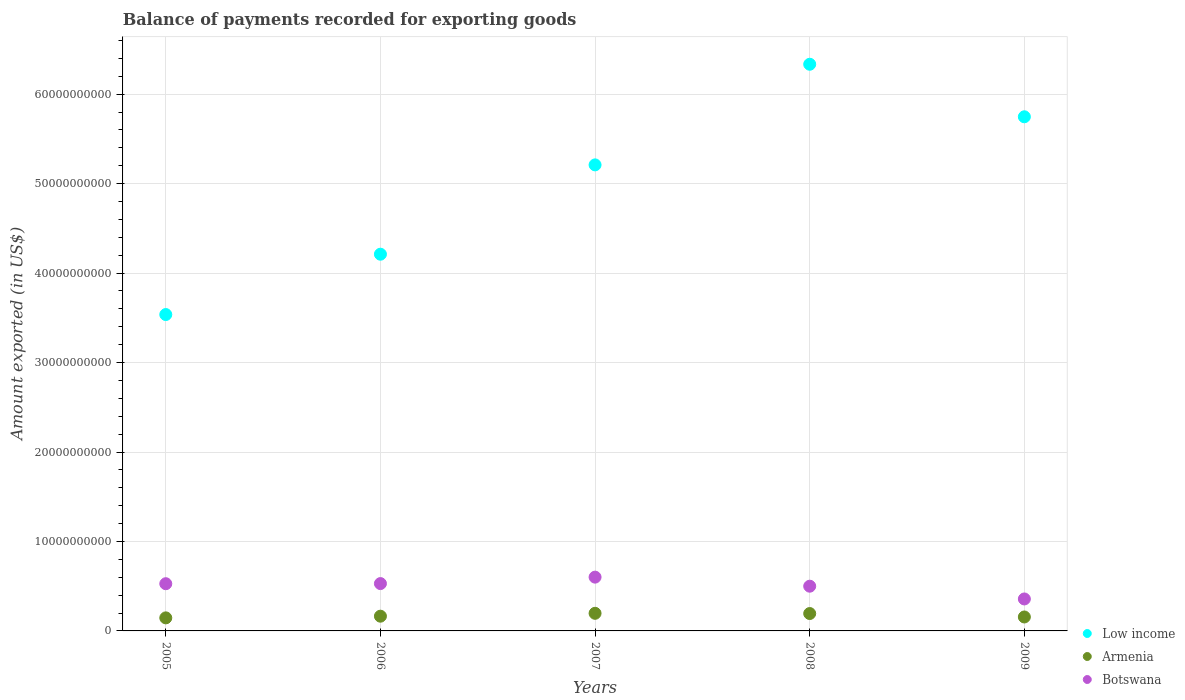How many different coloured dotlines are there?
Provide a succinct answer. 3. What is the amount exported in Low income in 2008?
Offer a very short reply. 6.33e+1. Across all years, what is the maximum amount exported in Low income?
Keep it short and to the point. 6.33e+1. Across all years, what is the minimum amount exported in Armenia?
Keep it short and to the point. 1.46e+09. In which year was the amount exported in Low income maximum?
Make the answer very short. 2008. In which year was the amount exported in Low income minimum?
Keep it short and to the point. 2005. What is the total amount exported in Armenia in the graph?
Ensure brevity in your answer.  8.58e+09. What is the difference between the amount exported in Botswana in 2007 and that in 2009?
Provide a short and direct response. 2.44e+09. What is the difference between the amount exported in Low income in 2005 and the amount exported in Armenia in 2007?
Make the answer very short. 3.34e+1. What is the average amount exported in Low income per year?
Offer a very short reply. 5.01e+1. In the year 2005, what is the difference between the amount exported in Botswana and amount exported in Armenia?
Provide a short and direct response. 3.82e+09. In how many years, is the amount exported in Low income greater than 26000000000 US$?
Give a very brief answer. 5. What is the ratio of the amount exported in Armenia in 2008 to that in 2009?
Your answer should be compact. 1.25. What is the difference between the highest and the second highest amount exported in Armenia?
Provide a succinct answer. 2.48e+07. What is the difference between the highest and the lowest amount exported in Armenia?
Give a very brief answer. 5.10e+08. In how many years, is the amount exported in Armenia greater than the average amount exported in Armenia taken over all years?
Give a very brief answer. 2. Does the amount exported in Armenia monotonically increase over the years?
Provide a short and direct response. No. Is the amount exported in Botswana strictly greater than the amount exported in Low income over the years?
Provide a short and direct response. No. Are the values on the major ticks of Y-axis written in scientific E-notation?
Provide a short and direct response. No. Does the graph contain grids?
Give a very brief answer. Yes. How many legend labels are there?
Your answer should be compact. 3. What is the title of the graph?
Your response must be concise. Balance of payments recorded for exporting goods. What is the label or title of the Y-axis?
Make the answer very short. Amount exported (in US$). What is the Amount exported (in US$) in Low income in 2005?
Your response must be concise. 3.54e+1. What is the Amount exported (in US$) in Armenia in 2005?
Keep it short and to the point. 1.46e+09. What is the Amount exported (in US$) in Botswana in 2005?
Your response must be concise. 5.28e+09. What is the Amount exported (in US$) of Low income in 2006?
Ensure brevity in your answer.  4.21e+1. What is the Amount exported (in US$) of Armenia in 2006?
Give a very brief answer. 1.65e+09. What is the Amount exported (in US$) in Botswana in 2006?
Your answer should be compact. 5.29e+09. What is the Amount exported (in US$) of Low income in 2007?
Offer a terse response. 5.21e+1. What is the Amount exported (in US$) in Armenia in 2007?
Keep it short and to the point. 1.97e+09. What is the Amount exported (in US$) in Botswana in 2007?
Offer a very short reply. 6.01e+09. What is the Amount exported (in US$) in Low income in 2008?
Offer a very short reply. 6.33e+1. What is the Amount exported (in US$) in Armenia in 2008?
Provide a short and direct response. 1.94e+09. What is the Amount exported (in US$) of Botswana in 2008?
Give a very brief answer. 5.00e+09. What is the Amount exported (in US$) in Low income in 2009?
Keep it short and to the point. 5.75e+1. What is the Amount exported (in US$) of Armenia in 2009?
Provide a succinct answer. 1.56e+09. What is the Amount exported (in US$) in Botswana in 2009?
Provide a succinct answer. 3.57e+09. Across all years, what is the maximum Amount exported (in US$) in Low income?
Your answer should be very brief. 6.33e+1. Across all years, what is the maximum Amount exported (in US$) of Armenia?
Provide a succinct answer. 1.97e+09. Across all years, what is the maximum Amount exported (in US$) of Botswana?
Provide a short and direct response. 6.01e+09. Across all years, what is the minimum Amount exported (in US$) of Low income?
Offer a terse response. 3.54e+1. Across all years, what is the minimum Amount exported (in US$) of Armenia?
Offer a very short reply. 1.46e+09. Across all years, what is the minimum Amount exported (in US$) in Botswana?
Ensure brevity in your answer.  3.57e+09. What is the total Amount exported (in US$) in Low income in the graph?
Provide a short and direct response. 2.50e+11. What is the total Amount exported (in US$) in Armenia in the graph?
Keep it short and to the point. 8.58e+09. What is the total Amount exported (in US$) in Botswana in the graph?
Keep it short and to the point. 2.52e+1. What is the difference between the Amount exported (in US$) of Low income in 2005 and that in 2006?
Make the answer very short. -6.74e+09. What is the difference between the Amount exported (in US$) in Armenia in 2005 and that in 2006?
Offer a terse response. -1.88e+08. What is the difference between the Amount exported (in US$) in Botswana in 2005 and that in 2006?
Provide a succinct answer. -1.42e+07. What is the difference between the Amount exported (in US$) in Low income in 2005 and that in 2007?
Provide a succinct answer. -1.67e+1. What is the difference between the Amount exported (in US$) in Armenia in 2005 and that in 2007?
Keep it short and to the point. -5.10e+08. What is the difference between the Amount exported (in US$) in Botswana in 2005 and that in 2007?
Your answer should be very brief. -7.35e+08. What is the difference between the Amount exported (in US$) of Low income in 2005 and that in 2008?
Provide a short and direct response. -2.80e+1. What is the difference between the Amount exported (in US$) of Armenia in 2005 and that in 2008?
Provide a short and direct response. -4.85e+08. What is the difference between the Amount exported (in US$) of Botswana in 2005 and that in 2008?
Your answer should be very brief. 2.78e+08. What is the difference between the Amount exported (in US$) of Low income in 2005 and that in 2009?
Make the answer very short. -2.21e+1. What is the difference between the Amount exported (in US$) of Armenia in 2005 and that in 2009?
Keep it short and to the point. -1.00e+08. What is the difference between the Amount exported (in US$) in Botswana in 2005 and that in 2009?
Provide a succinct answer. 1.70e+09. What is the difference between the Amount exported (in US$) in Low income in 2006 and that in 2007?
Ensure brevity in your answer.  -9.99e+09. What is the difference between the Amount exported (in US$) in Armenia in 2006 and that in 2007?
Your answer should be very brief. -3.22e+08. What is the difference between the Amount exported (in US$) in Botswana in 2006 and that in 2007?
Keep it short and to the point. -7.20e+08. What is the difference between the Amount exported (in US$) in Low income in 2006 and that in 2008?
Keep it short and to the point. -2.12e+1. What is the difference between the Amount exported (in US$) in Armenia in 2006 and that in 2008?
Offer a terse response. -2.97e+08. What is the difference between the Amount exported (in US$) of Botswana in 2006 and that in 2008?
Offer a very short reply. 2.92e+08. What is the difference between the Amount exported (in US$) in Low income in 2006 and that in 2009?
Give a very brief answer. -1.54e+1. What is the difference between the Amount exported (in US$) of Armenia in 2006 and that in 2009?
Offer a very short reply. 8.74e+07. What is the difference between the Amount exported (in US$) of Botswana in 2006 and that in 2009?
Give a very brief answer. 1.72e+09. What is the difference between the Amount exported (in US$) of Low income in 2007 and that in 2008?
Your response must be concise. -1.12e+1. What is the difference between the Amount exported (in US$) of Armenia in 2007 and that in 2008?
Give a very brief answer. 2.48e+07. What is the difference between the Amount exported (in US$) in Botswana in 2007 and that in 2008?
Your answer should be very brief. 1.01e+09. What is the difference between the Amount exported (in US$) in Low income in 2007 and that in 2009?
Keep it short and to the point. -5.38e+09. What is the difference between the Amount exported (in US$) in Armenia in 2007 and that in 2009?
Make the answer very short. 4.09e+08. What is the difference between the Amount exported (in US$) of Botswana in 2007 and that in 2009?
Offer a terse response. 2.44e+09. What is the difference between the Amount exported (in US$) in Low income in 2008 and that in 2009?
Your answer should be very brief. 5.87e+09. What is the difference between the Amount exported (in US$) in Armenia in 2008 and that in 2009?
Your response must be concise. 3.84e+08. What is the difference between the Amount exported (in US$) in Botswana in 2008 and that in 2009?
Offer a terse response. 1.43e+09. What is the difference between the Amount exported (in US$) of Low income in 2005 and the Amount exported (in US$) of Armenia in 2006?
Offer a terse response. 3.37e+1. What is the difference between the Amount exported (in US$) of Low income in 2005 and the Amount exported (in US$) of Botswana in 2006?
Make the answer very short. 3.01e+1. What is the difference between the Amount exported (in US$) in Armenia in 2005 and the Amount exported (in US$) in Botswana in 2006?
Your response must be concise. -3.83e+09. What is the difference between the Amount exported (in US$) in Low income in 2005 and the Amount exported (in US$) in Armenia in 2007?
Offer a very short reply. 3.34e+1. What is the difference between the Amount exported (in US$) of Low income in 2005 and the Amount exported (in US$) of Botswana in 2007?
Provide a short and direct response. 2.94e+1. What is the difference between the Amount exported (in US$) in Armenia in 2005 and the Amount exported (in US$) in Botswana in 2007?
Provide a succinct answer. -4.55e+09. What is the difference between the Amount exported (in US$) in Low income in 2005 and the Amount exported (in US$) in Armenia in 2008?
Offer a very short reply. 3.34e+1. What is the difference between the Amount exported (in US$) of Low income in 2005 and the Amount exported (in US$) of Botswana in 2008?
Provide a succinct answer. 3.04e+1. What is the difference between the Amount exported (in US$) of Armenia in 2005 and the Amount exported (in US$) of Botswana in 2008?
Give a very brief answer. -3.54e+09. What is the difference between the Amount exported (in US$) in Low income in 2005 and the Amount exported (in US$) in Armenia in 2009?
Offer a very short reply. 3.38e+1. What is the difference between the Amount exported (in US$) of Low income in 2005 and the Amount exported (in US$) of Botswana in 2009?
Your answer should be very brief. 3.18e+1. What is the difference between the Amount exported (in US$) in Armenia in 2005 and the Amount exported (in US$) in Botswana in 2009?
Offer a very short reply. -2.11e+09. What is the difference between the Amount exported (in US$) of Low income in 2006 and the Amount exported (in US$) of Armenia in 2007?
Make the answer very short. 4.01e+1. What is the difference between the Amount exported (in US$) in Low income in 2006 and the Amount exported (in US$) in Botswana in 2007?
Make the answer very short. 3.61e+1. What is the difference between the Amount exported (in US$) in Armenia in 2006 and the Amount exported (in US$) in Botswana in 2007?
Your answer should be compact. -4.37e+09. What is the difference between the Amount exported (in US$) of Low income in 2006 and the Amount exported (in US$) of Armenia in 2008?
Provide a short and direct response. 4.02e+1. What is the difference between the Amount exported (in US$) in Low income in 2006 and the Amount exported (in US$) in Botswana in 2008?
Your answer should be compact. 3.71e+1. What is the difference between the Amount exported (in US$) of Armenia in 2006 and the Amount exported (in US$) of Botswana in 2008?
Offer a very short reply. -3.35e+09. What is the difference between the Amount exported (in US$) of Low income in 2006 and the Amount exported (in US$) of Armenia in 2009?
Provide a succinct answer. 4.06e+1. What is the difference between the Amount exported (in US$) in Low income in 2006 and the Amount exported (in US$) in Botswana in 2009?
Your response must be concise. 3.85e+1. What is the difference between the Amount exported (in US$) in Armenia in 2006 and the Amount exported (in US$) in Botswana in 2009?
Give a very brief answer. -1.93e+09. What is the difference between the Amount exported (in US$) of Low income in 2007 and the Amount exported (in US$) of Armenia in 2008?
Your response must be concise. 5.02e+1. What is the difference between the Amount exported (in US$) of Low income in 2007 and the Amount exported (in US$) of Botswana in 2008?
Keep it short and to the point. 4.71e+1. What is the difference between the Amount exported (in US$) of Armenia in 2007 and the Amount exported (in US$) of Botswana in 2008?
Make the answer very short. -3.03e+09. What is the difference between the Amount exported (in US$) of Low income in 2007 and the Amount exported (in US$) of Armenia in 2009?
Keep it short and to the point. 5.05e+1. What is the difference between the Amount exported (in US$) in Low income in 2007 and the Amount exported (in US$) in Botswana in 2009?
Ensure brevity in your answer.  4.85e+1. What is the difference between the Amount exported (in US$) in Armenia in 2007 and the Amount exported (in US$) in Botswana in 2009?
Keep it short and to the point. -1.60e+09. What is the difference between the Amount exported (in US$) in Low income in 2008 and the Amount exported (in US$) in Armenia in 2009?
Offer a very short reply. 6.18e+1. What is the difference between the Amount exported (in US$) in Low income in 2008 and the Amount exported (in US$) in Botswana in 2009?
Your answer should be compact. 5.98e+1. What is the difference between the Amount exported (in US$) in Armenia in 2008 and the Amount exported (in US$) in Botswana in 2009?
Make the answer very short. -1.63e+09. What is the average Amount exported (in US$) in Low income per year?
Keep it short and to the point. 5.01e+1. What is the average Amount exported (in US$) of Armenia per year?
Your answer should be very brief. 1.72e+09. What is the average Amount exported (in US$) of Botswana per year?
Keep it short and to the point. 5.03e+09. In the year 2005, what is the difference between the Amount exported (in US$) of Low income and Amount exported (in US$) of Armenia?
Make the answer very short. 3.39e+1. In the year 2005, what is the difference between the Amount exported (in US$) of Low income and Amount exported (in US$) of Botswana?
Give a very brief answer. 3.01e+1. In the year 2005, what is the difference between the Amount exported (in US$) of Armenia and Amount exported (in US$) of Botswana?
Provide a short and direct response. -3.82e+09. In the year 2006, what is the difference between the Amount exported (in US$) in Low income and Amount exported (in US$) in Armenia?
Keep it short and to the point. 4.05e+1. In the year 2006, what is the difference between the Amount exported (in US$) of Low income and Amount exported (in US$) of Botswana?
Offer a terse response. 3.68e+1. In the year 2006, what is the difference between the Amount exported (in US$) of Armenia and Amount exported (in US$) of Botswana?
Offer a very short reply. -3.64e+09. In the year 2007, what is the difference between the Amount exported (in US$) of Low income and Amount exported (in US$) of Armenia?
Your response must be concise. 5.01e+1. In the year 2007, what is the difference between the Amount exported (in US$) in Low income and Amount exported (in US$) in Botswana?
Offer a very short reply. 4.61e+1. In the year 2007, what is the difference between the Amount exported (in US$) in Armenia and Amount exported (in US$) in Botswana?
Offer a terse response. -4.04e+09. In the year 2008, what is the difference between the Amount exported (in US$) of Low income and Amount exported (in US$) of Armenia?
Ensure brevity in your answer.  6.14e+1. In the year 2008, what is the difference between the Amount exported (in US$) of Low income and Amount exported (in US$) of Botswana?
Ensure brevity in your answer.  5.83e+1. In the year 2008, what is the difference between the Amount exported (in US$) of Armenia and Amount exported (in US$) of Botswana?
Make the answer very short. -3.06e+09. In the year 2009, what is the difference between the Amount exported (in US$) of Low income and Amount exported (in US$) of Armenia?
Keep it short and to the point. 5.59e+1. In the year 2009, what is the difference between the Amount exported (in US$) of Low income and Amount exported (in US$) of Botswana?
Offer a terse response. 5.39e+1. In the year 2009, what is the difference between the Amount exported (in US$) in Armenia and Amount exported (in US$) in Botswana?
Your response must be concise. -2.01e+09. What is the ratio of the Amount exported (in US$) of Low income in 2005 to that in 2006?
Keep it short and to the point. 0.84. What is the ratio of the Amount exported (in US$) in Armenia in 2005 to that in 2006?
Your response must be concise. 0.89. What is the ratio of the Amount exported (in US$) in Low income in 2005 to that in 2007?
Ensure brevity in your answer.  0.68. What is the ratio of the Amount exported (in US$) in Armenia in 2005 to that in 2007?
Give a very brief answer. 0.74. What is the ratio of the Amount exported (in US$) of Botswana in 2005 to that in 2007?
Your response must be concise. 0.88. What is the ratio of the Amount exported (in US$) of Low income in 2005 to that in 2008?
Your answer should be compact. 0.56. What is the ratio of the Amount exported (in US$) in Armenia in 2005 to that in 2008?
Offer a terse response. 0.75. What is the ratio of the Amount exported (in US$) of Botswana in 2005 to that in 2008?
Offer a very short reply. 1.06. What is the ratio of the Amount exported (in US$) in Low income in 2005 to that in 2009?
Keep it short and to the point. 0.62. What is the ratio of the Amount exported (in US$) in Armenia in 2005 to that in 2009?
Give a very brief answer. 0.94. What is the ratio of the Amount exported (in US$) in Botswana in 2005 to that in 2009?
Ensure brevity in your answer.  1.48. What is the ratio of the Amount exported (in US$) in Low income in 2006 to that in 2007?
Your response must be concise. 0.81. What is the ratio of the Amount exported (in US$) of Armenia in 2006 to that in 2007?
Provide a short and direct response. 0.84. What is the ratio of the Amount exported (in US$) in Botswana in 2006 to that in 2007?
Your answer should be very brief. 0.88. What is the ratio of the Amount exported (in US$) in Low income in 2006 to that in 2008?
Your answer should be compact. 0.66. What is the ratio of the Amount exported (in US$) in Armenia in 2006 to that in 2008?
Offer a very short reply. 0.85. What is the ratio of the Amount exported (in US$) in Botswana in 2006 to that in 2008?
Offer a terse response. 1.06. What is the ratio of the Amount exported (in US$) of Low income in 2006 to that in 2009?
Offer a very short reply. 0.73. What is the ratio of the Amount exported (in US$) of Armenia in 2006 to that in 2009?
Offer a very short reply. 1.06. What is the ratio of the Amount exported (in US$) of Botswana in 2006 to that in 2009?
Your answer should be very brief. 1.48. What is the ratio of the Amount exported (in US$) in Low income in 2007 to that in 2008?
Your response must be concise. 0.82. What is the ratio of the Amount exported (in US$) in Armenia in 2007 to that in 2008?
Your answer should be compact. 1.01. What is the ratio of the Amount exported (in US$) of Botswana in 2007 to that in 2008?
Your answer should be very brief. 1.2. What is the ratio of the Amount exported (in US$) in Low income in 2007 to that in 2009?
Ensure brevity in your answer.  0.91. What is the ratio of the Amount exported (in US$) of Armenia in 2007 to that in 2009?
Your answer should be very brief. 1.26. What is the ratio of the Amount exported (in US$) of Botswana in 2007 to that in 2009?
Keep it short and to the point. 1.68. What is the ratio of the Amount exported (in US$) in Low income in 2008 to that in 2009?
Your answer should be compact. 1.1. What is the ratio of the Amount exported (in US$) in Armenia in 2008 to that in 2009?
Make the answer very short. 1.25. What is the ratio of the Amount exported (in US$) in Botswana in 2008 to that in 2009?
Ensure brevity in your answer.  1.4. What is the difference between the highest and the second highest Amount exported (in US$) in Low income?
Give a very brief answer. 5.87e+09. What is the difference between the highest and the second highest Amount exported (in US$) in Armenia?
Your response must be concise. 2.48e+07. What is the difference between the highest and the second highest Amount exported (in US$) of Botswana?
Your response must be concise. 7.20e+08. What is the difference between the highest and the lowest Amount exported (in US$) in Low income?
Your answer should be very brief. 2.80e+1. What is the difference between the highest and the lowest Amount exported (in US$) of Armenia?
Offer a very short reply. 5.10e+08. What is the difference between the highest and the lowest Amount exported (in US$) in Botswana?
Offer a terse response. 2.44e+09. 